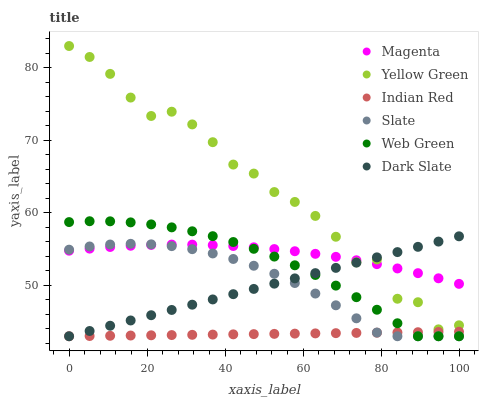Does Indian Red have the minimum area under the curve?
Answer yes or no. Yes. Does Yellow Green have the maximum area under the curve?
Answer yes or no. Yes. Does Slate have the minimum area under the curve?
Answer yes or no. No. Does Slate have the maximum area under the curve?
Answer yes or no. No. Is Dark Slate the smoothest?
Answer yes or no. Yes. Is Yellow Green the roughest?
Answer yes or no. Yes. Is Slate the smoothest?
Answer yes or no. No. Is Slate the roughest?
Answer yes or no. No. Does Slate have the lowest value?
Answer yes or no. Yes. Does Magenta have the lowest value?
Answer yes or no. No. Does Yellow Green have the highest value?
Answer yes or no. Yes. Does Slate have the highest value?
Answer yes or no. No. Is Indian Red less than Yellow Green?
Answer yes or no. Yes. Is Magenta greater than Indian Red?
Answer yes or no. Yes. Does Yellow Green intersect Dark Slate?
Answer yes or no. Yes. Is Yellow Green less than Dark Slate?
Answer yes or no. No. Is Yellow Green greater than Dark Slate?
Answer yes or no. No. Does Indian Red intersect Yellow Green?
Answer yes or no. No. 